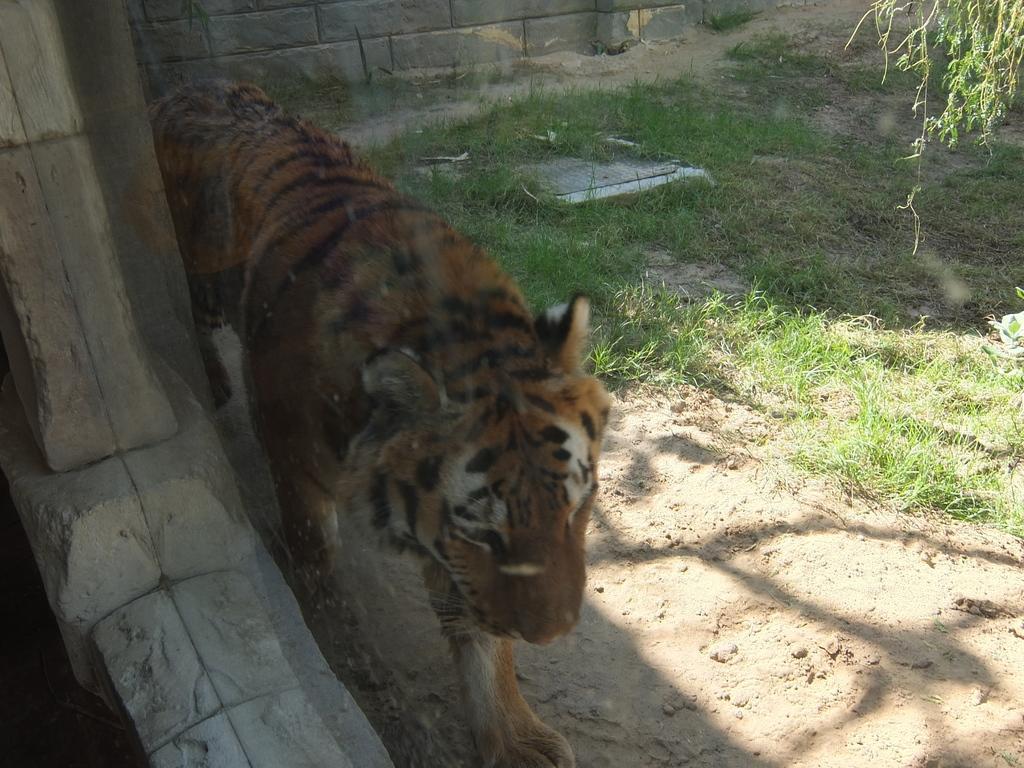Can you describe this image briefly? In this image, we can see a yellow color tiger, there is some grass on the ground, we can see a wall. 